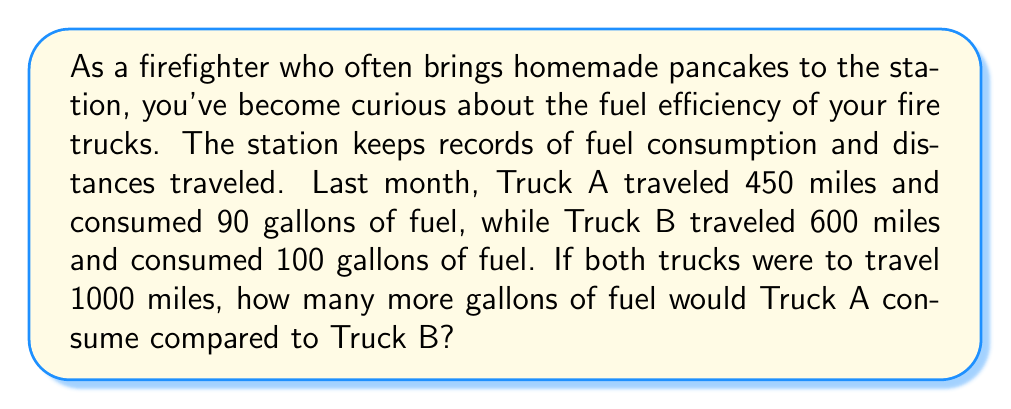Can you solve this math problem? Let's approach this step-by-step:

1) First, we need to calculate the fuel efficiency (miles per gallon) for each truck:

   For Truck A: $\text{Efficiency}_A = \frac{450 \text{ miles}}{90 \text{ gallons}} = 5 \text{ miles/gallon}$

   For Truck B: $\text{Efficiency}_B = \frac{600 \text{ miles}}{100 \text{ gallons}} = 6 \text{ miles/gallon}$

2) Now, we need to determine how many gallons each truck would consume to travel 1000 miles:

   For Truck A: $\text{Fuel}_A = \frac{1000 \text{ miles}}{5 \text{ miles/gallon}} = 200 \text{ gallons}$

   For Truck B: $\text{Fuel}_B = \frac{1000 \text{ miles}}{6 \text{ miles/gallon}} = 166.67 \text{ gallons}$

3) To find how many more gallons Truck A would consume compared to Truck B:

   $\text{Difference} = \text{Fuel}_A - \text{Fuel}_B = 200 - 166.67 = 33.33 \text{ gallons}$

Therefore, Truck A would consume 33.33 gallons more fuel than Truck B to travel 1000 miles.
Answer: 33.33 gallons 